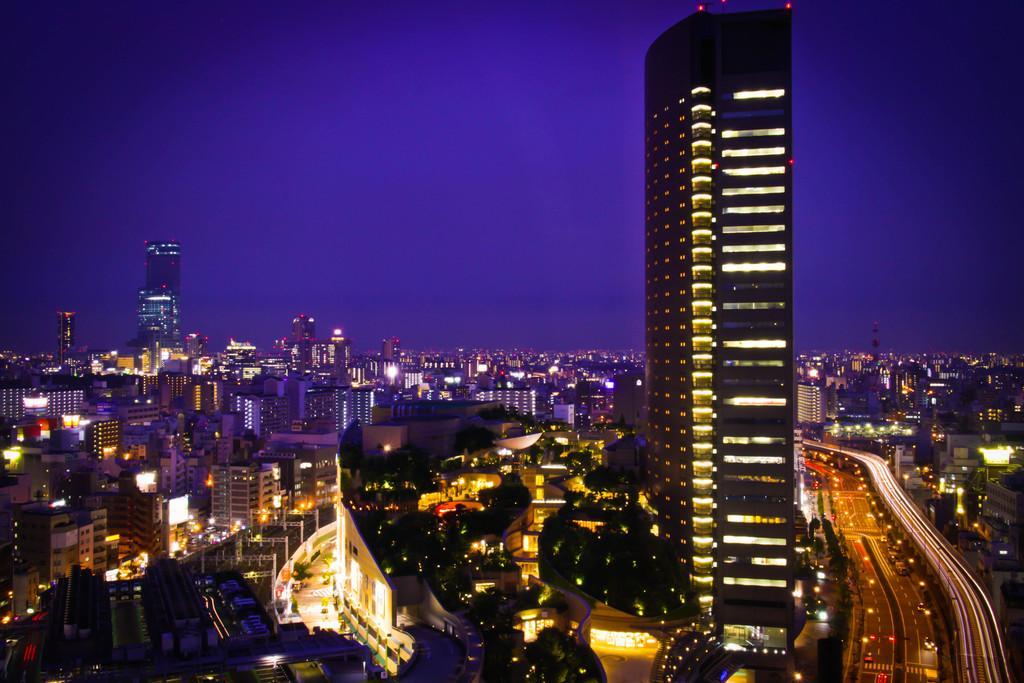In one or two sentences, can you explain what this image depicts? In this image I can see the buildings. I can see the lights. On the right side, I can see some vehicles on the road. 